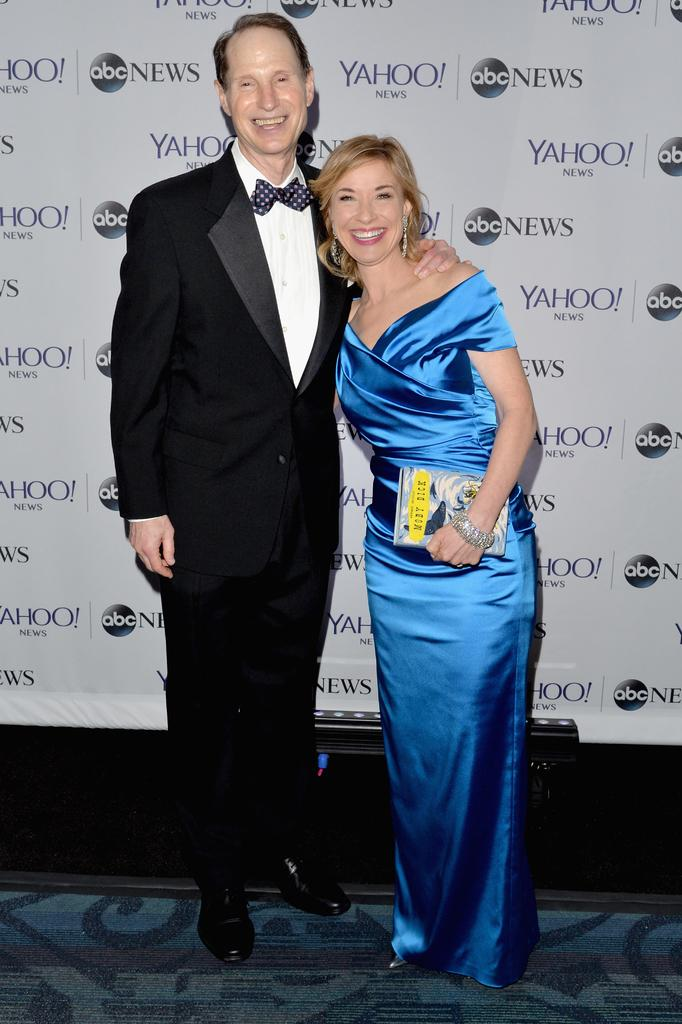What is the main subject of the image? There is a man and a lady standing in the center of the image. What is the lady holding in the image? The lady is holding a book. What can be seen in the background of the image? There is a board in the background of the image. What is visible at the bottom of the image? There is a floor visible at the bottom of the image. What type of cart can be seen in the image? There is no cart present in the image. Is the lady taking a bath in the image? There is no indication of a bath or any water-related activity in the image. 